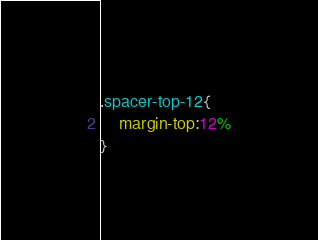<code> <loc_0><loc_0><loc_500><loc_500><_CSS_>.spacer-top-12{
    margin-top:12%
}</code> 